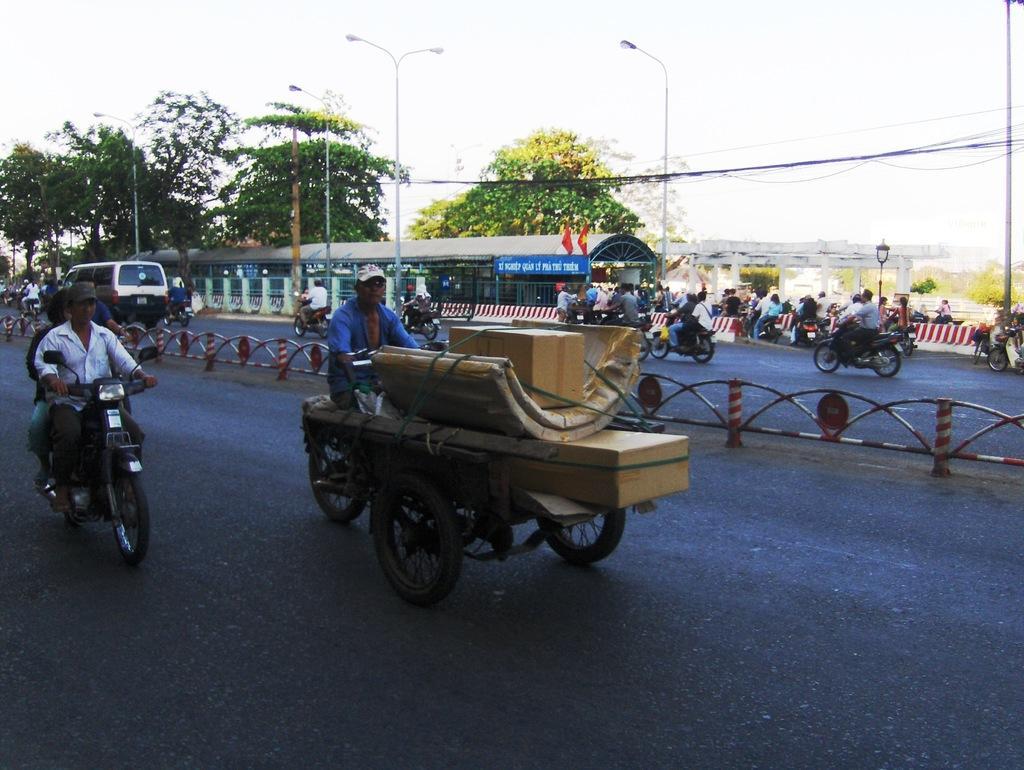In one or two sentences, can you explain what this image depicts? In this picture we can see a cart, people riding motorcycles and a vehicle on the road and in the background we can see a shelter, fences, bridge, streetlights and the sky. 